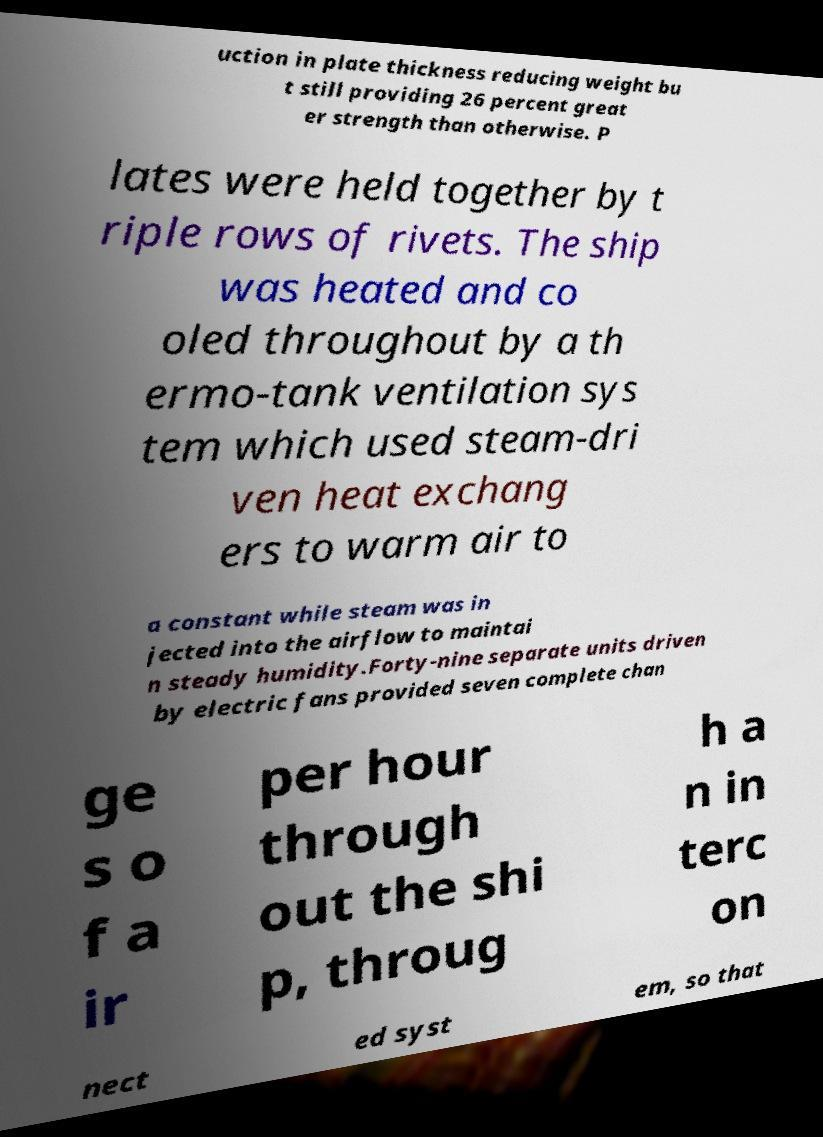Can you read and provide the text displayed in the image?This photo seems to have some interesting text. Can you extract and type it out for me? uction in plate thickness reducing weight bu t still providing 26 percent great er strength than otherwise. P lates were held together by t riple rows of rivets. The ship was heated and co oled throughout by a th ermo-tank ventilation sys tem which used steam-dri ven heat exchang ers to warm air to a constant while steam was in jected into the airflow to maintai n steady humidity.Forty-nine separate units driven by electric fans provided seven complete chan ge s o f a ir per hour through out the shi p, throug h a n in terc on nect ed syst em, so that 